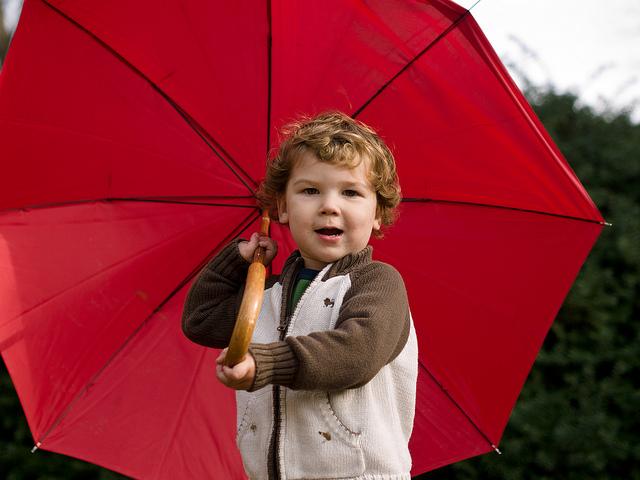Is the umbrella a rain umbrella?
Answer briefly. Yes. What is the boy holding?
Concise answer only. Umbrella. What side  of the hand is seen?
Give a very brief answer. Inside. Is the boys jacket partially closed with buttons or a zipper?
Quick response, please. Zipper. Is the umbrella too big?
Be succinct. Yes. 